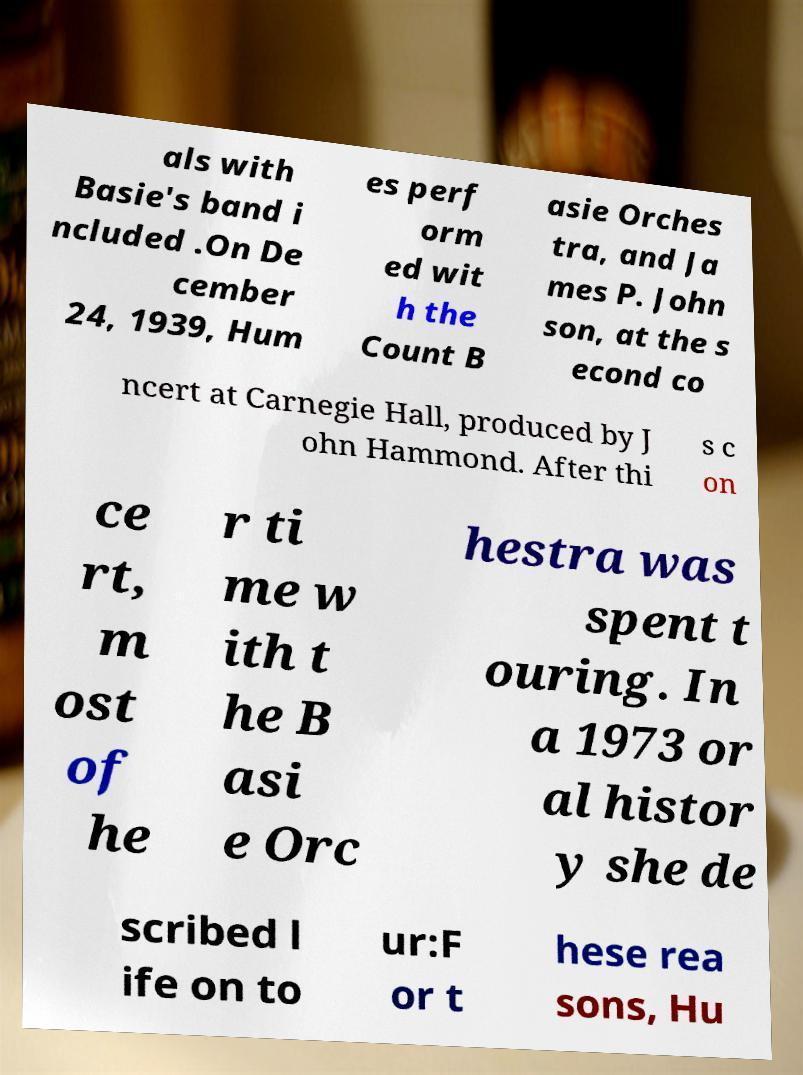I need the written content from this picture converted into text. Can you do that? als with Basie's band i ncluded .On De cember 24, 1939, Hum es perf orm ed wit h the Count B asie Orches tra, and Ja mes P. John son, at the s econd co ncert at Carnegie Hall, produced by J ohn Hammond. After thi s c on ce rt, m ost of he r ti me w ith t he B asi e Orc hestra was spent t ouring. In a 1973 or al histor y she de scribed l ife on to ur:F or t hese rea sons, Hu 